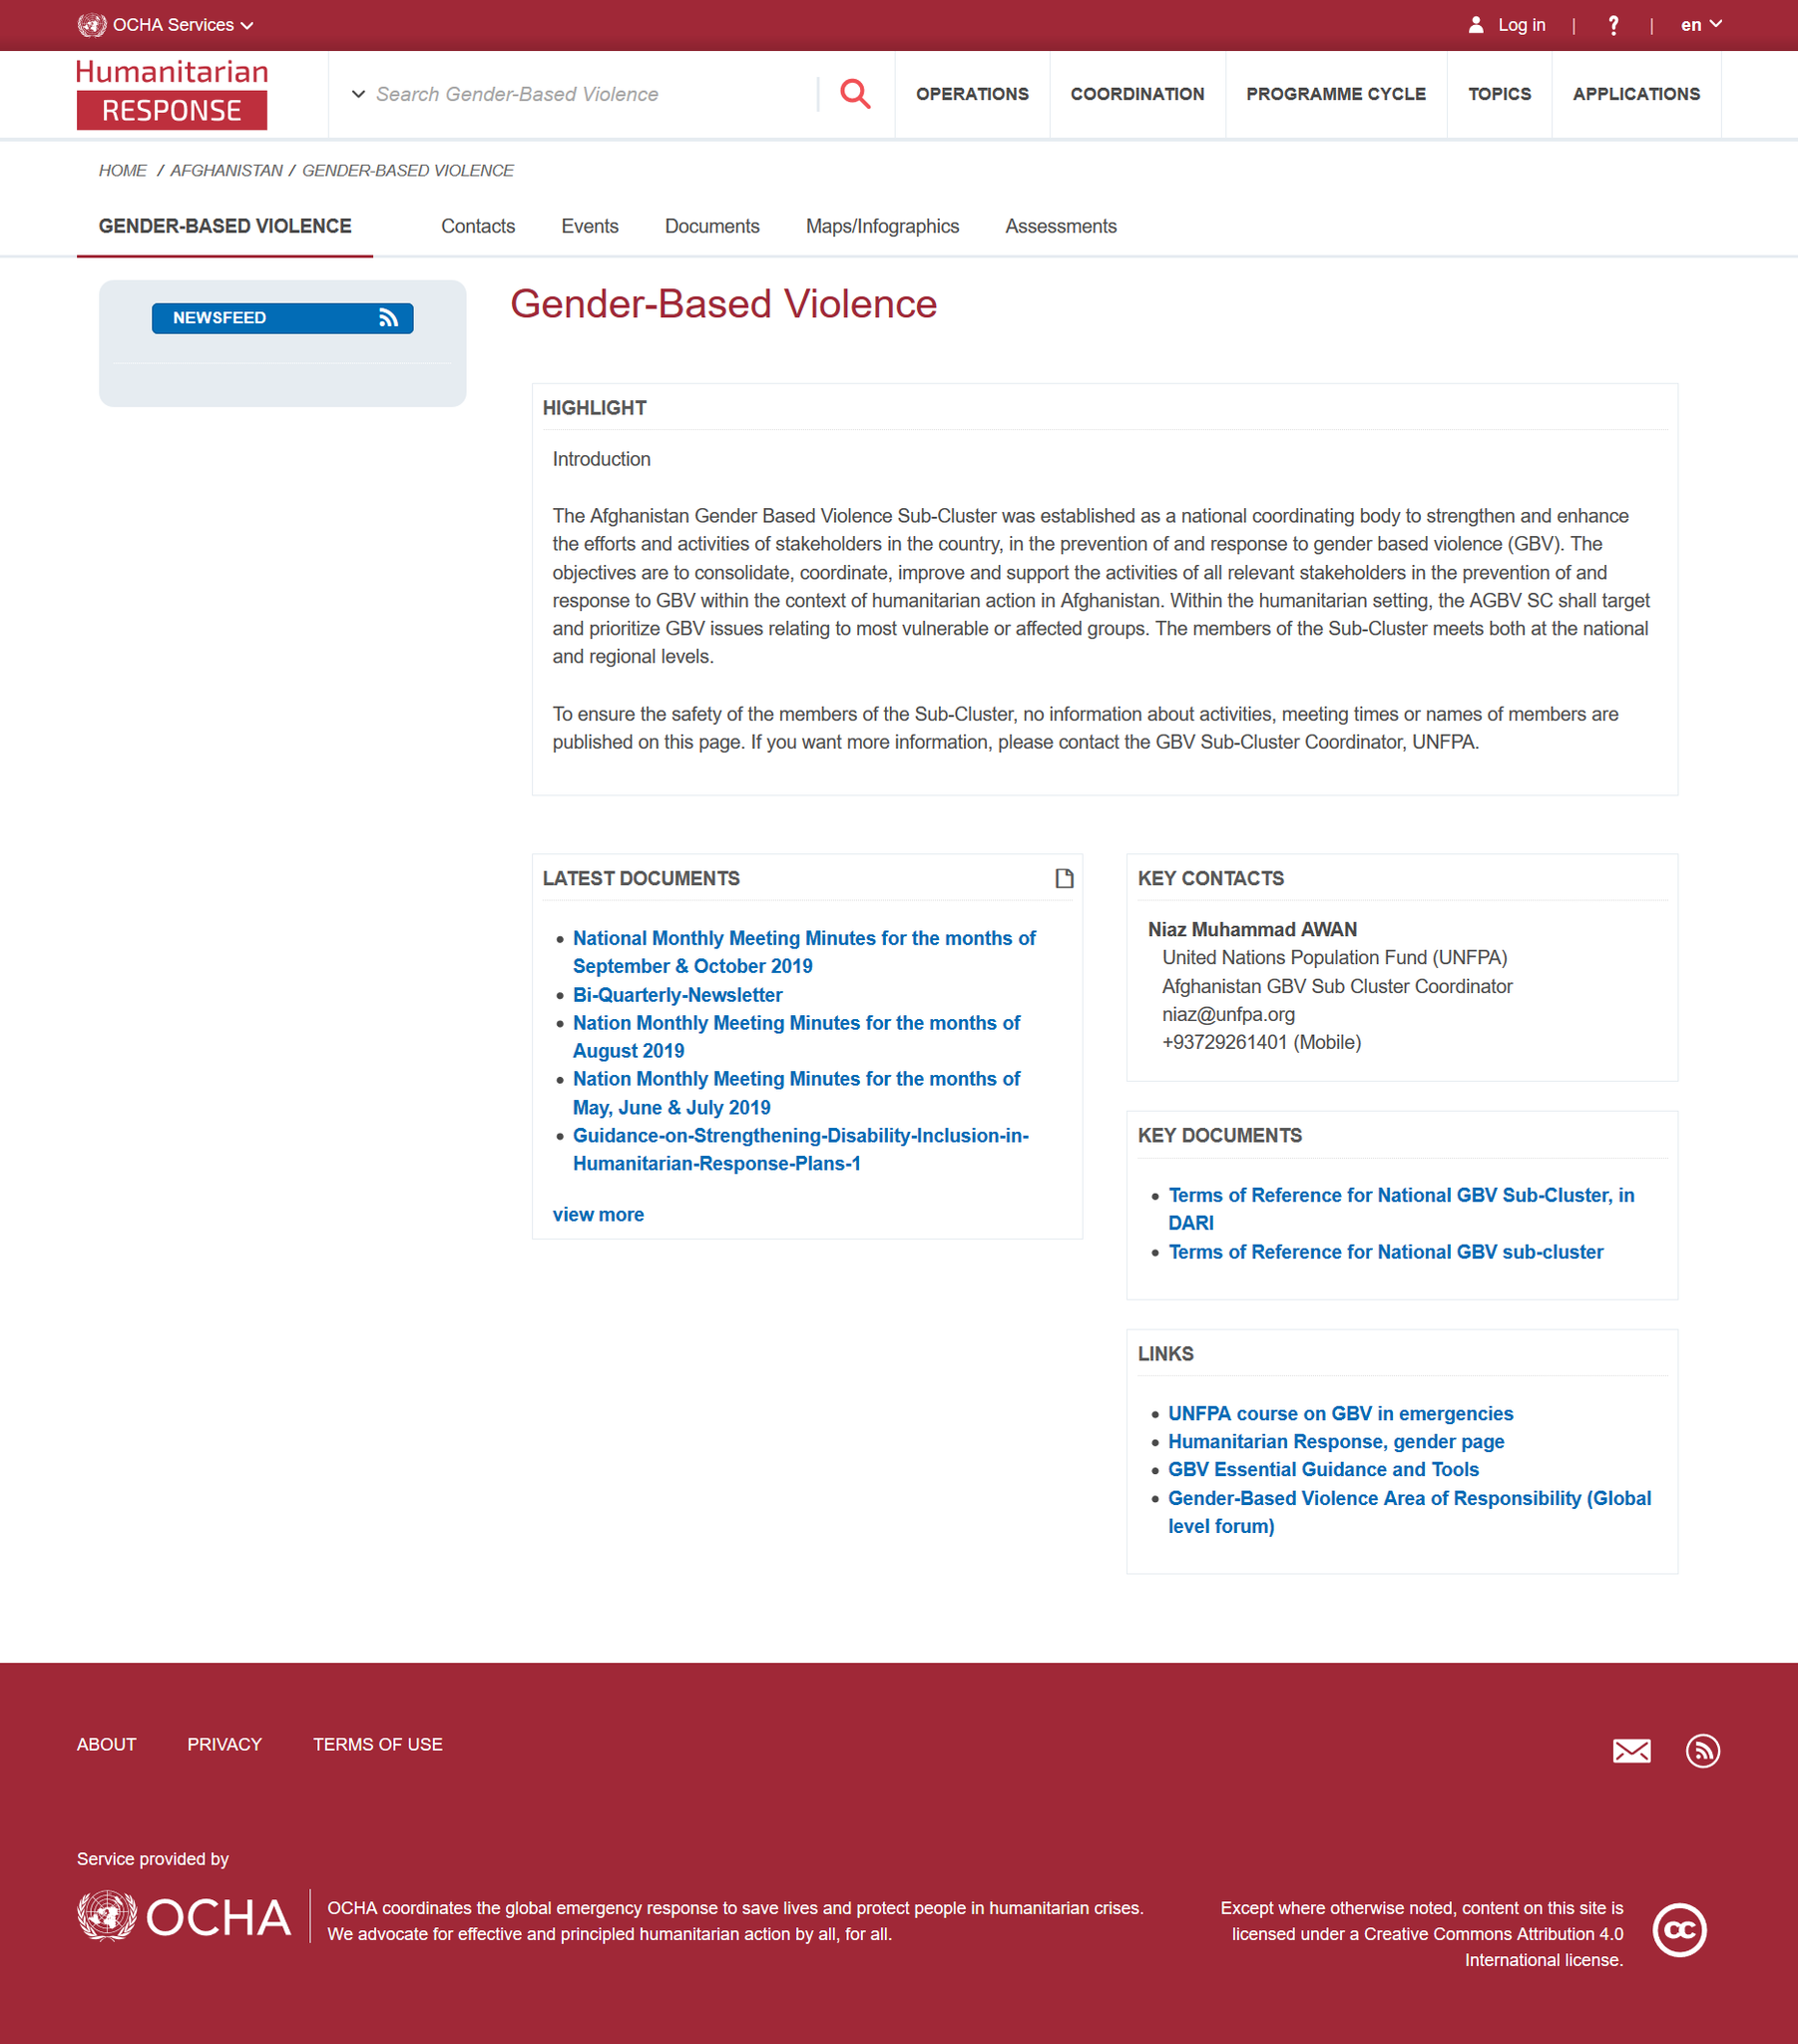Indicate a few pertinent items in this graphic. The GBV Sub-Cluster Coordinator, UNFPA, should be contacted for more information. To protect the safety of the members of the Gender-Based Violence Sub-Cluster, their names are not published on this page. The GBV Sub-Cluster has been established in Afghanistan. 